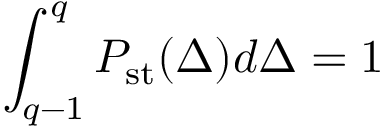<formula> <loc_0><loc_0><loc_500><loc_500>\int _ { q - 1 } ^ { q } P _ { s t } ( \Delta ) d \Delta = 1</formula> 